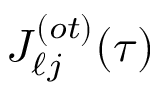<formula> <loc_0><loc_0><loc_500><loc_500>J _ { \ell j } ^ { ( o t ) } ( \tau )</formula> 